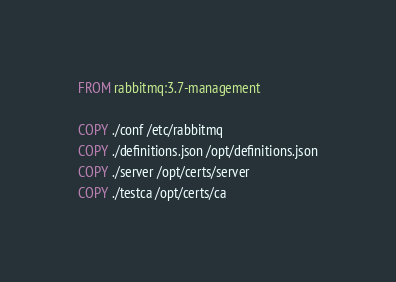<code> <loc_0><loc_0><loc_500><loc_500><_Dockerfile_>FROM rabbitmq:3.7-management

COPY ./conf /etc/rabbitmq
COPY ./definitions.json /opt/definitions.json
COPY ./server /opt/certs/server
COPY ./testca /opt/certs/ca

</code> 